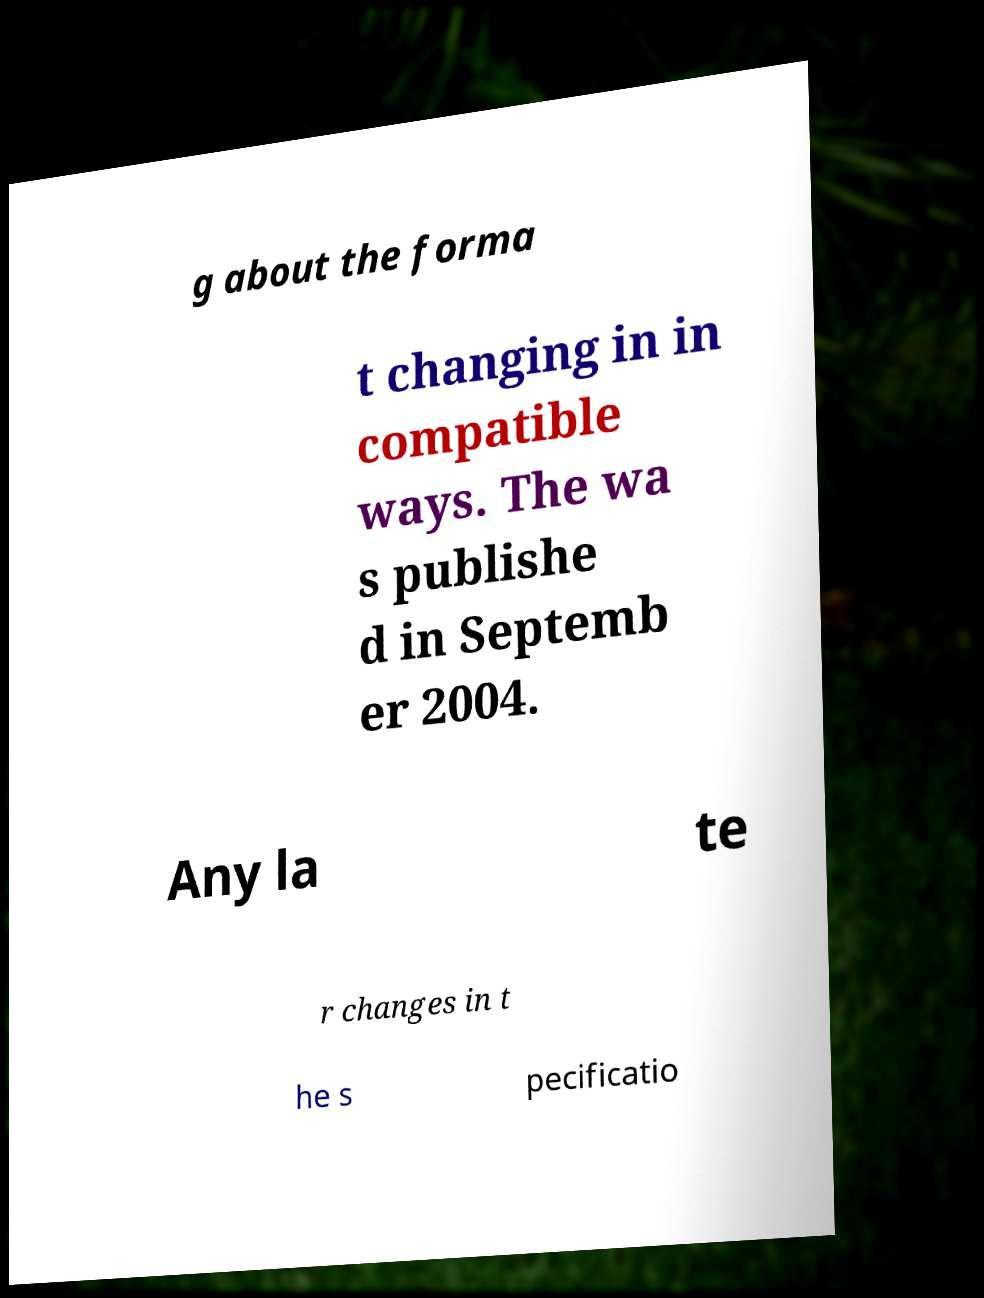There's text embedded in this image that I need extracted. Can you transcribe it verbatim? g about the forma t changing in in compatible ways. The wa s publishe d in Septemb er 2004. Any la te r changes in t he s pecificatio 